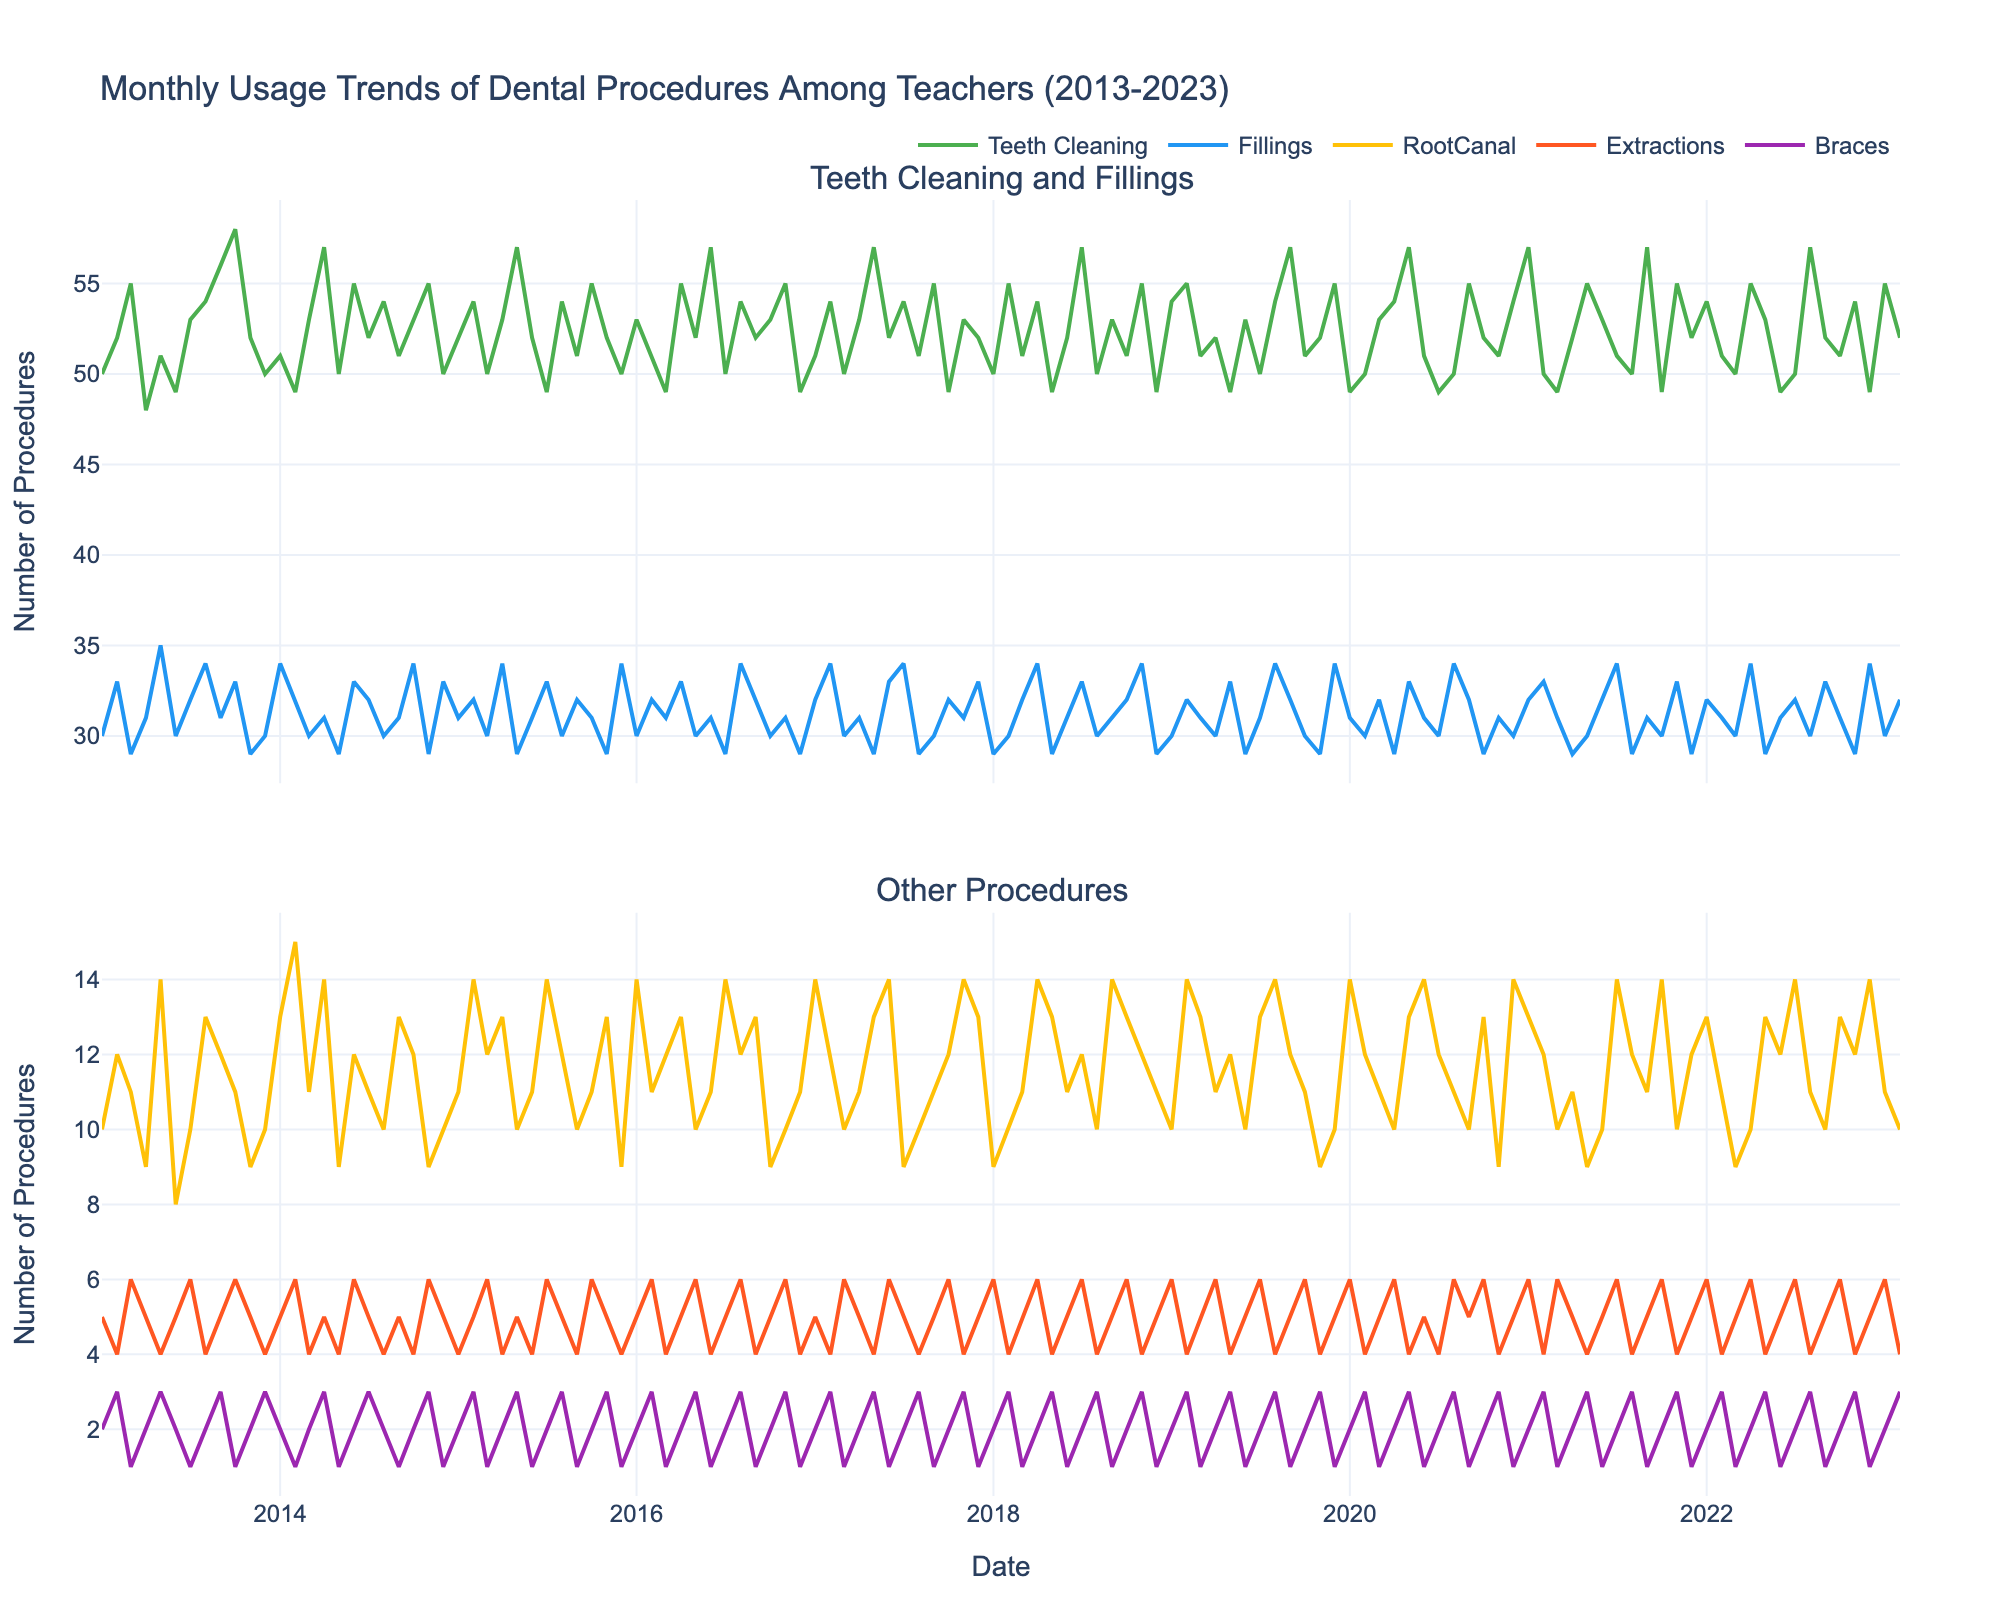What is the title of the figure? The title of the figure can usually be found at the top of the plot, indicating the main subject or focus. In this case, look at the top of the plot.
Answer: Monthly Usage Trends of Dental Procedures Among Teachers (2013-2023) How many different dental procedures are tracked in this figure? Count the number of different procedures listed in the legend or shown in the plot. There should be five distinct lines each representing a different procedure.
Answer: Five Which dental procedure has the highest number of monthly usages overall? This can be observed by identifying the line that consistently has the highest values in the plot. Look for the line that peaks highest throughout the years.
Answer: Teeth Cleaning During which year and month did Fillings reach their peak usage? Follow the trend line for Fillings and identify the highest point on this line. Then note the corresponding year and month.
Answer: June 2022 Between Root Canal and Braces, which procedure showed more monthly usages in March 2017? Locate March 2017 on the x-axis, then compare the y-values of Root Canal and Braces for this specific month.
Answer: Root Canal What is the average monthly usage of Extractions in 2015? Sum all the monthly values for Extractions in the year 2015 and divide by 12 (number of months). The monthly values are 5, 5, 6, 4, 5, 4, 6, 5, 4, 6, 5, 4. The sum is 59, and the average is 59/12.
Answer: 4.92 Which year shows the highest variability in the monthly usage of Teeth Cleaning? Observe the fluctuation in the Teeth Cleaning line for each year. The year with the most ups and downs (highest range between minimum and maximum) indicates higher variability.
Answer: 2013 Does Braces usage show any clear seasonal patterns? Examine the Braces trend across years to see if there are peaks or troughs during specific months repeatedly. Check for consistent increases or decreases in places such as summer or winter.
Answer: No clear pattern By how much did Teeth Cleaning usage change from January 2017 to January 2022? Locate the January data points for 2017 and 2022 for Teeth Cleaning, then calculate the difference between these two points.
Answer: Increased by 1 Which dental procedure remains comparatively stable over the years? Look for the procedure line that changes the least over the plotted years, indicating stability. Focus on minimal fluctuations and consistency in trends.
Answer: Root Canal 